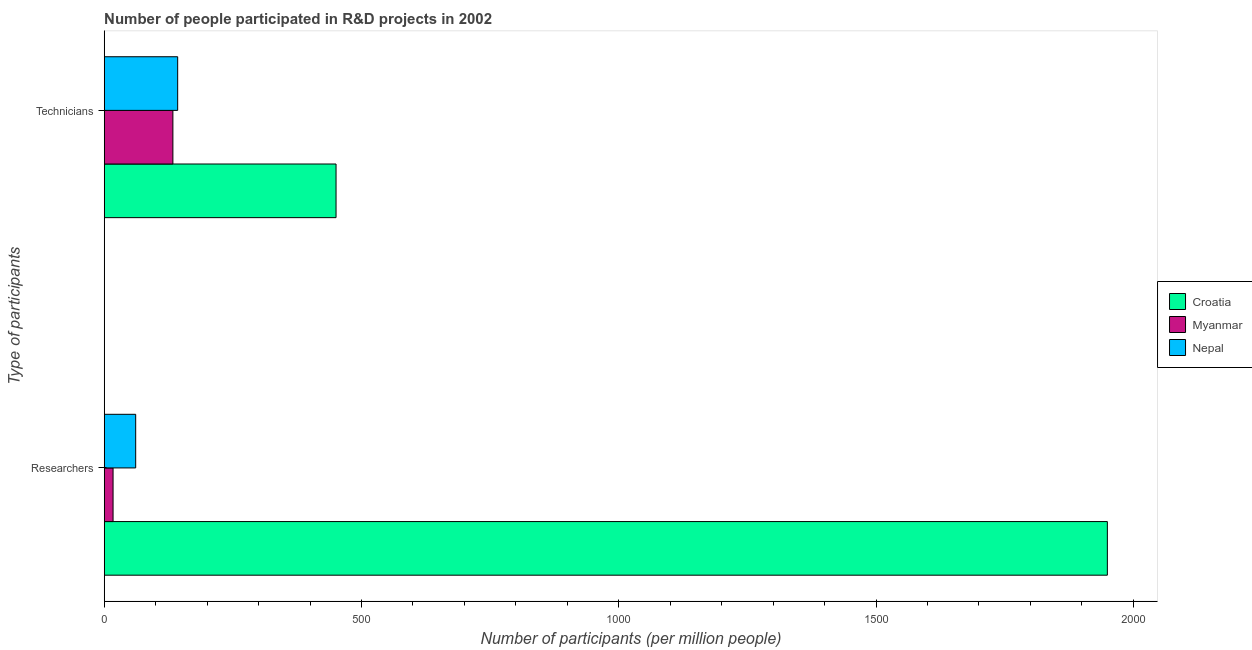How many different coloured bars are there?
Your answer should be very brief. 3. How many groups of bars are there?
Keep it short and to the point. 2. Are the number of bars per tick equal to the number of legend labels?
Provide a succinct answer. Yes. What is the label of the 1st group of bars from the top?
Make the answer very short. Technicians. What is the number of researchers in Nepal?
Offer a very short reply. 61.18. Across all countries, what is the maximum number of technicians?
Offer a very short reply. 450.56. Across all countries, what is the minimum number of technicians?
Your answer should be very brief. 133.48. In which country was the number of researchers maximum?
Provide a short and direct response. Croatia. In which country was the number of researchers minimum?
Keep it short and to the point. Myanmar. What is the total number of researchers in the graph?
Your answer should be very brief. 2027.99. What is the difference between the number of researchers in Nepal and that in Croatia?
Give a very brief answer. -1888.43. What is the difference between the number of researchers in Croatia and the number of technicians in Myanmar?
Ensure brevity in your answer.  1816.14. What is the average number of technicians per country?
Give a very brief answer. 242.26. What is the difference between the number of technicians and number of researchers in Croatia?
Provide a succinct answer. -1499.06. In how many countries, is the number of researchers greater than 1000 ?
Ensure brevity in your answer.  1. What is the ratio of the number of technicians in Myanmar to that in Nepal?
Your answer should be compact. 0.93. In how many countries, is the number of researchers greater than the average number of researchers taken over all countries?
Your answer should be compact. 1. What does the 3rd bar from the top in Technicians represents?
Your response must be concise. Croatia. What does the 2nd bar from the bottom in Technicians represents?
Your response must be concise. Myanmar. How many bars are there?
Ensure brevity in your answer.  6. Are all the bars in the graph horizontal?
Provide a short and direct response. Yes. How many countries are there in the graph?
Your response must be concise. 3. Are the values on the major ticks of X-axis written in scientific E-notation?
Your response must be concise. No. Where does the legend appear in the graph?
Give a very brief answer. Center right. How many legend labels are there?
Your response must be concise. 3. What is the title of the graph?
Offer a very short reply. Number of people participated in R&D projects in 2002. Does "Croatia" appear as one of the legend labels in the graph?
Your answer should be compact. Yes. What is the label or title of the X-axis?
Give a very brief answer. Number of participants (per million people). What is the label or title of the Y-axis?
Offer a terse response. Type of participants. What is the Number of participants (per million people) of Croatia in Researchers?
Your answer should be compact. 1949.62. What is the Number of participants (per million people) of Myanmar in Researchers?
Offer a terse response. 17.19. What is the Number of participants (per million people) in Nepal in Researchers?
Keep it short and to the point. 61.18. What is the Number of participants (per million people) in Croatia in Technicians?
Your answer should be very brief. 450.56. What is the Number of participants (per million people) in Myanmar in Technicians?
Give a very brief answer. 133.48. What is the Number of participants (per million people) of Nepal in Technicians?
Keep it short and to the point. 142.76. Across all Type of participants, what is the maximum Number of participants (per million people) in Croatia?
Give a very brief answer. 1949.62. Across all Type of participants, what is the maximum Number of participants (per million people) in Myanmar?
Offer a very short reply. 133.48. Across all Type of participants, what is the maximum Number of participants (per million people) in Nepal?
Your answer should be compact. 142.76. Across all Type of participants, what is the minimum Number of participants (per million people) of Croatia?
Your answer should be compact. 450.56. Across all Type of participants, what is the minimum Number of participants (per million people) of Myanmar?
Provide a short and direct response. 17.19. Across all Type of participants, what is the minimum Number of participants (per million people) of Nepal?
Provide a succinct answer. 61.18. What is the total Number of participants (per million people) of Croatia in the graph?
Give a very brief answer. 2400.17. What is the total Number of participants (per million people) of Myanmar in the graph?
Provide a short and direct response. 150.67. What is the total Number of participants (per million people) of Nepal in the graph?
Your answer should be compact. 203.94. What is the difference between the Number of participants (per million people) in Croatia in Researchers and that in Technicians?
Provide a succinct answer. 1499.06. What is the difference between the Number of participants (per million people) of Myanmar in Researchers and that in Technicians?
Give a very brief answer. -116.29. What is the difference between the Number of participants (per million people) of Nepal in Researchers and that in Technicians?
Make the answer very short. -81.58. What is the difference between the Number of participants (per million people) of Croatia in Researchers and the Number of participants (per million people) of Myanmar in Technicians?
Your answer should be very brief. 1816.14. What is the difference between the Number of participants (per million people) of Croatia in Researchers and the Number of participants (per million people) of Nepal in Technicians?
Your answer should be compact. 1806.86. What is the difference between the Number of participants (per million people) of Myanmar in Researchers and the Number of participants (per million people) of Nepal in Technicians?
Make the answer very short. -125.57. What is the average Number of participants (per million people) in Croatia per Type of participants?
Offer a very short reply. 1200.09. What is the average Number of participants (per million people) of Myanmar per Type of participants?
Your response must be concise. 75.33. What is the average Number of participants (per million people) of Nepal per Type of participants?
Give a very brief answer. 101.97. What is the difference between the Number of participants (per million people) of Croatia and Number of participants (per million people) of Myanmar in Researchers?
Provide a short and direct response. 1932.42. What is the difference between the Number of participants (per million people) of Croatia and Number of participants (per million people) of Nepal in Researchers?
Your answer should be compact. 1888.43. What is the difference between the Number of participants (per million people) of Myanmar and Number of participants (per million people) of Nepal in Researchers?
Your answer should be very brief. -43.99. What is the difference between the Number of participants (per million people) in Croatia and Number of participants (per million people) in Myanmar in Technicians?
Offer a terse response. 317.08. What is the difference between the Number of participants (per million people) of Croatia and Number of participants (per million people) of Nepal in Technicians?
Offer a terse response. 307.8. What is the difference between the Number of participants (per million people) of Myanmar and Number of participants (per million people) of Nepal in Technicians?
Provide a succinct answer. -9.28. What is the ratio of the Number of participants (per million people) in Croatia in Researchers to that in Technicians?
Your answer should be very brief. 4.33. What is the ratio of the Number of participants (per million people) of Myanmar in Researchers to that in Technicians?
Give a very brief answer. 0.13. What is the ratio of the Number of participants (per million people) in Nepal in Researchers to that in Technicians?
Ensure brevity in your answer.  0.43. What is the difference between the highest and the second highest Number of participants (per million people) in Croatia?
Provide a succinct answer. 1499.06. What is the difference between the highest and the second highest Number of participants (per million people) of Myanmar?
Your answer should be compact. 116.29. What is the difference between the highest and the second highest Number of participants (per million people) of Nepal?
Your answer should be very brief. 81.58. What is the difference between the highest and the lowest Number of participants (per million people) of Croatia?
Your answer should be very brief. 1499.06. What is the difference between the highest and the lowest Number of participants (per million people) of Myanmar?
Provide a short and direct response. 116.29. What is the difference between the highest and the lowest Number of participants (per million people) in Nepal?
Give a very brief answer. 81.58. 